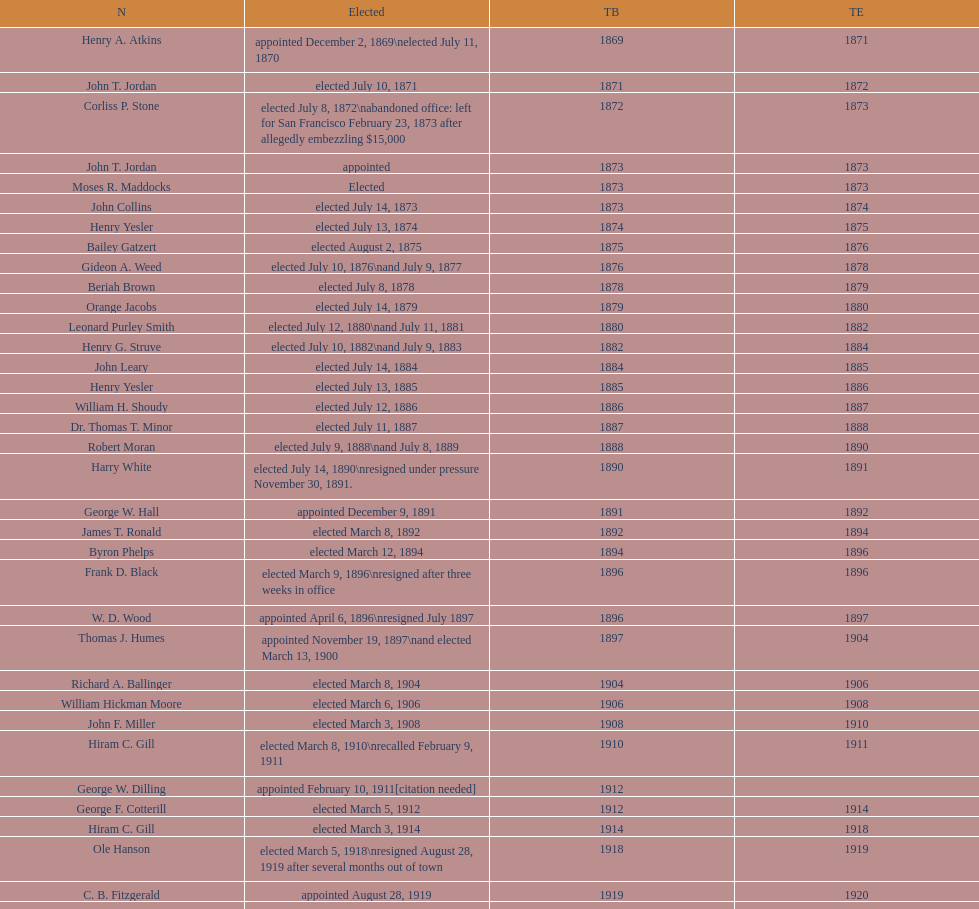Which mayor seattle, washington resigned after only three weeks in office in 1896? Frank D. Black. 